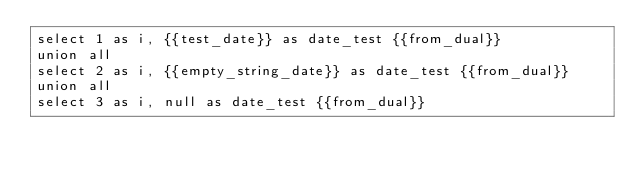<code> <loc_0><loc_0><loc_500><loc_500><_SQL_>select 1 as i, {{test_date}} as date_test {{from_dual}}
union all
select 2 as i, {{empty_string_date}} as date_test {{from_dual}}
union all
select 3 as i, null as date_test {{from_dual}}
</code> 